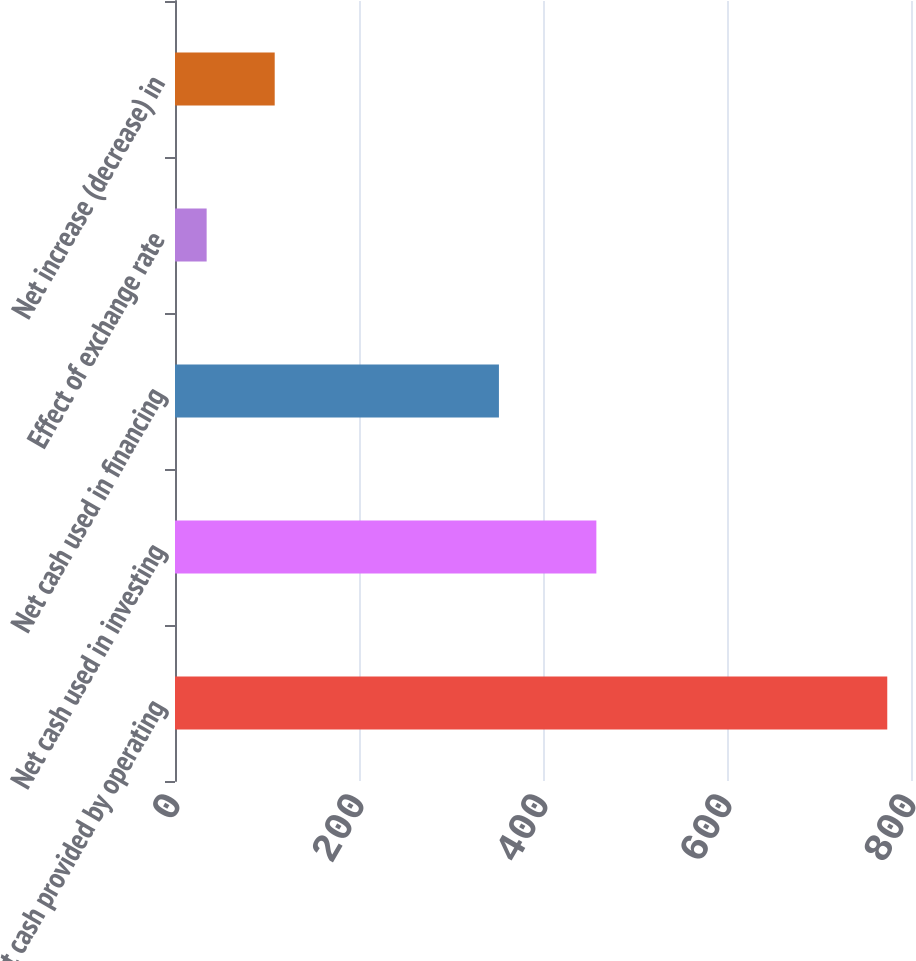<chart> <loc_0><loc_0><loc_500><loc_500><bar_chart><fcel>Net cash provided by operating<fcel>Net cash used in investing<fcel>Net cash used in financing<fcel>Effect of exchange rate<fcel>Net increase (decrease) in<nl><fcel>774.2<fcel>458<fcel>352.1<fcel>34.4<fcel>108.38<nl></chart> 